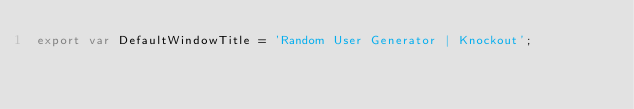<code> <loc_0><loc_0><loc_500><loc_500><_JavaScript_>export var DefaultWindowTitle = 'Random User Generator | Knockout';
</code> 